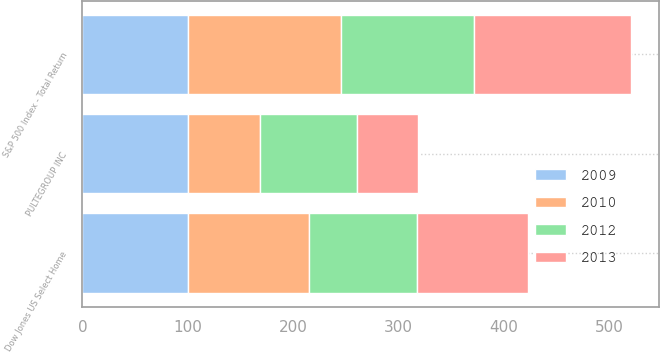<chart> <loc_0><loc_0><loc_500><loc_500><stacked_bar_chart><ecel><fcel>PULTEGROUP INC<fcel>S&P 500 Index - Total Return<fcel>Dow Jones US Select Home<nl><fcel>2009<fcel>100<fcel>100<fcel>100<nl><fcel>2012<fcel>91.49<fcel>126.47<fcel>103.13<nl><fcel>2010<fcel>68.8<fcel>145.52<fcel>114.65<nl><fcel>2013<fcel>57.73<fcel>148.59<fcel>104.9<nl></chart> 